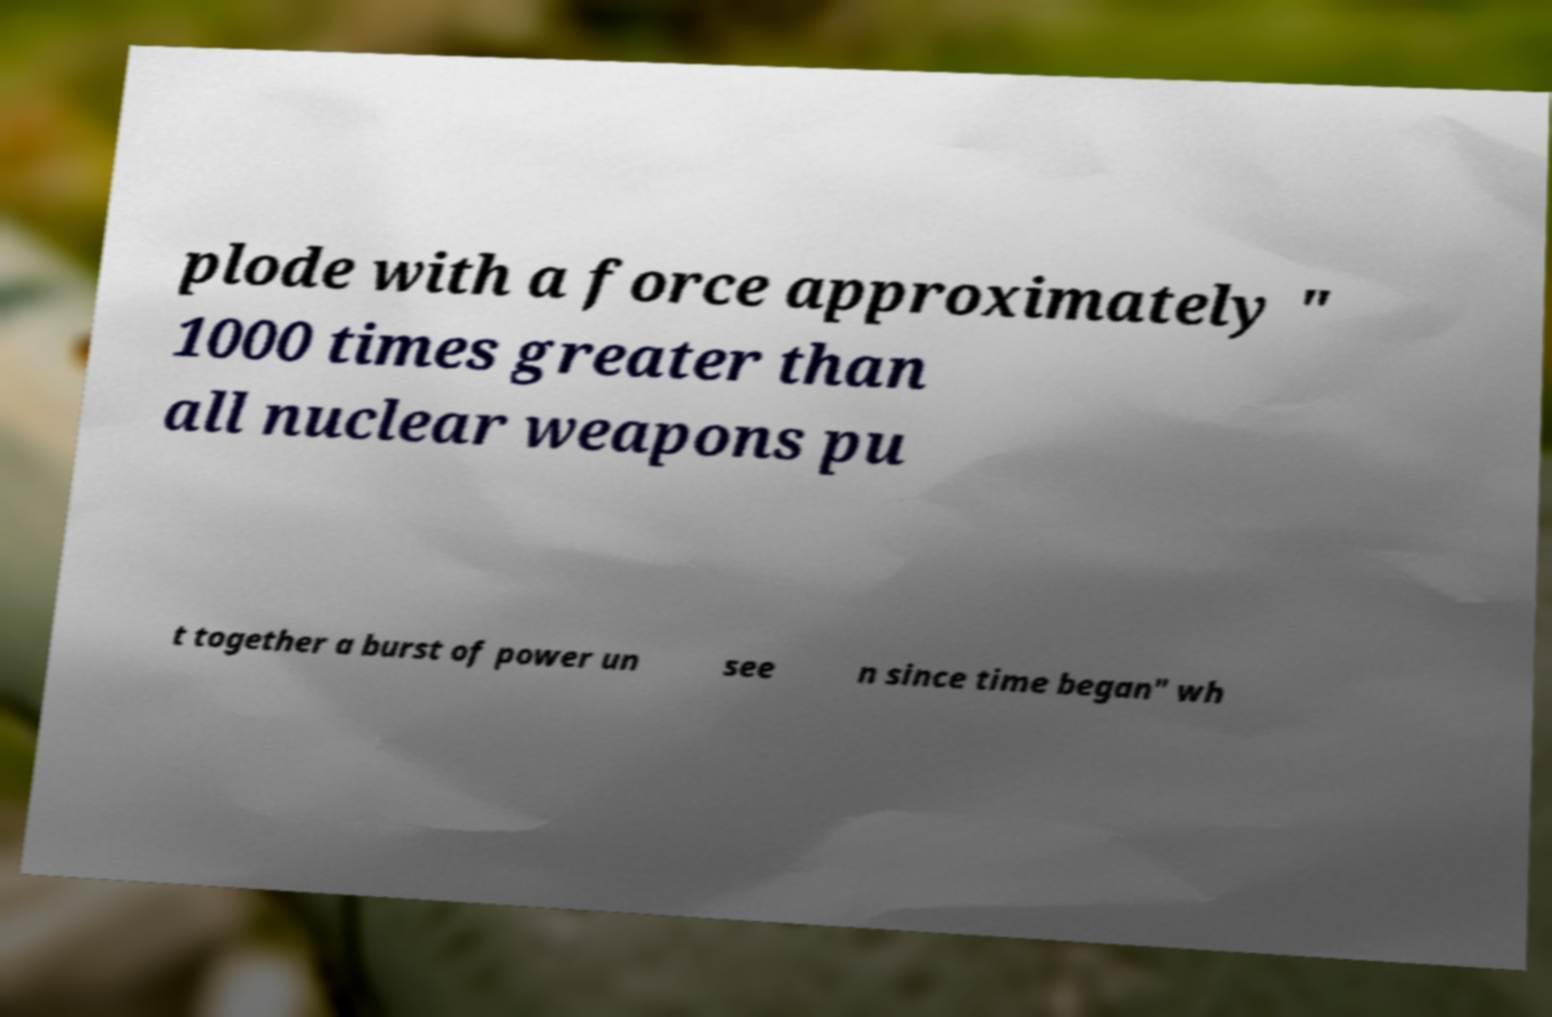Please read and relay the text visible in this image. What does it say? plode with a force approximately " 1000 times greater than all nuclear weapons pu t together a burst of power un see n since time began" wh 